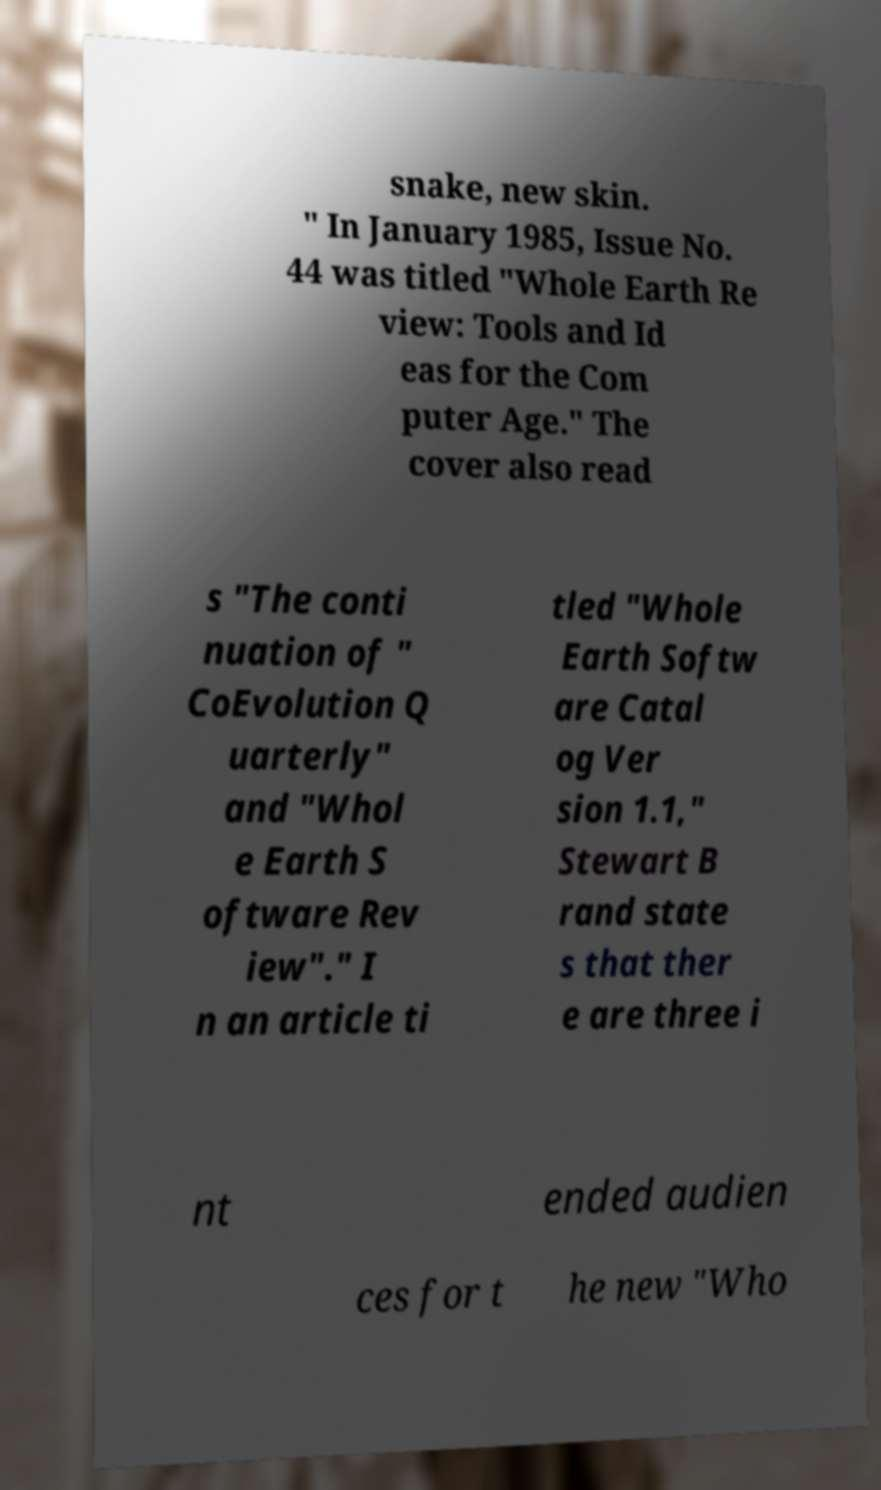Please read and relay the text visible in this image. What does it say? snake, new skin. " In January 1985, Issue No. 44 was titled "Whole Earth Re view: Tools and Id eas for the Com puter Age." The cover also read s "The conti nuation of " CoEvolution Q uarterly" and "Whol e Earth S oftware Rev iew"." I n an article ti tled "Whole Earth Softw are Catal og Ver sion 1.1," Stewart B rand state s that ther e are three i nt ended audien ces for t he new "Who 